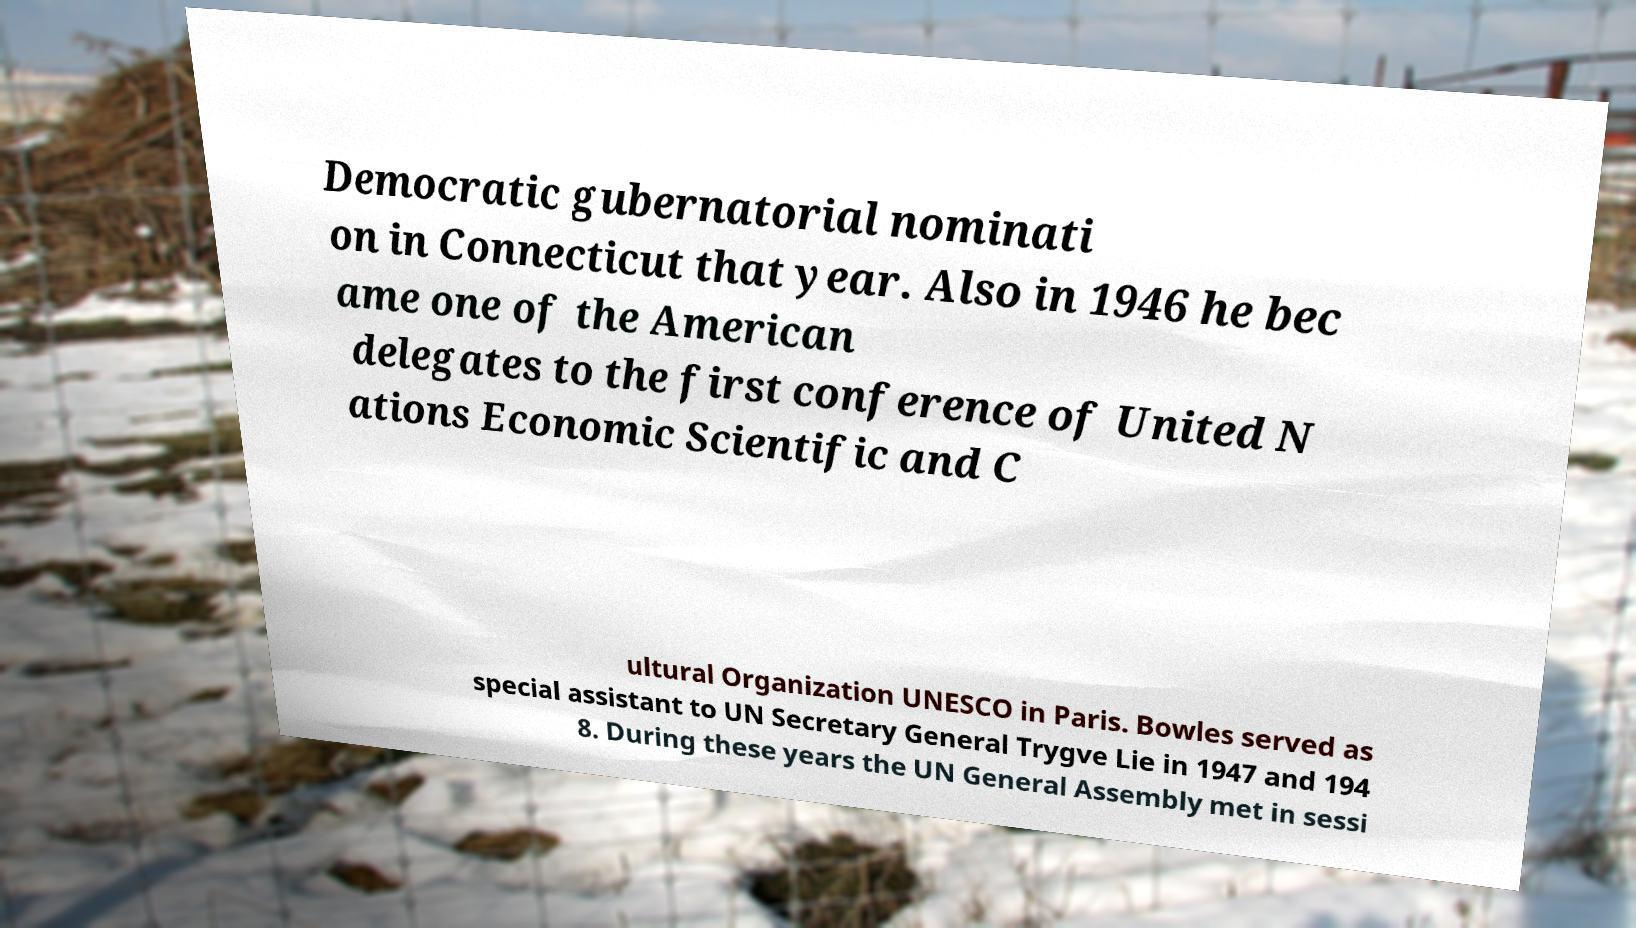There's text embedded in this image that I need extracted. Can you transcribe it verbatim? Democratic gubernatorial nominati on in Connecticut that year. Also in 1946 he bec ame one of the American delegates to the first conference of United N ations Economic Scientific and C ultural Organization UNESCO in Paris. Bowles served as special assistant to UN Secretary General Trygve Lie in 1947 and 194 8. During these years the UN General Assembly met in sessi 